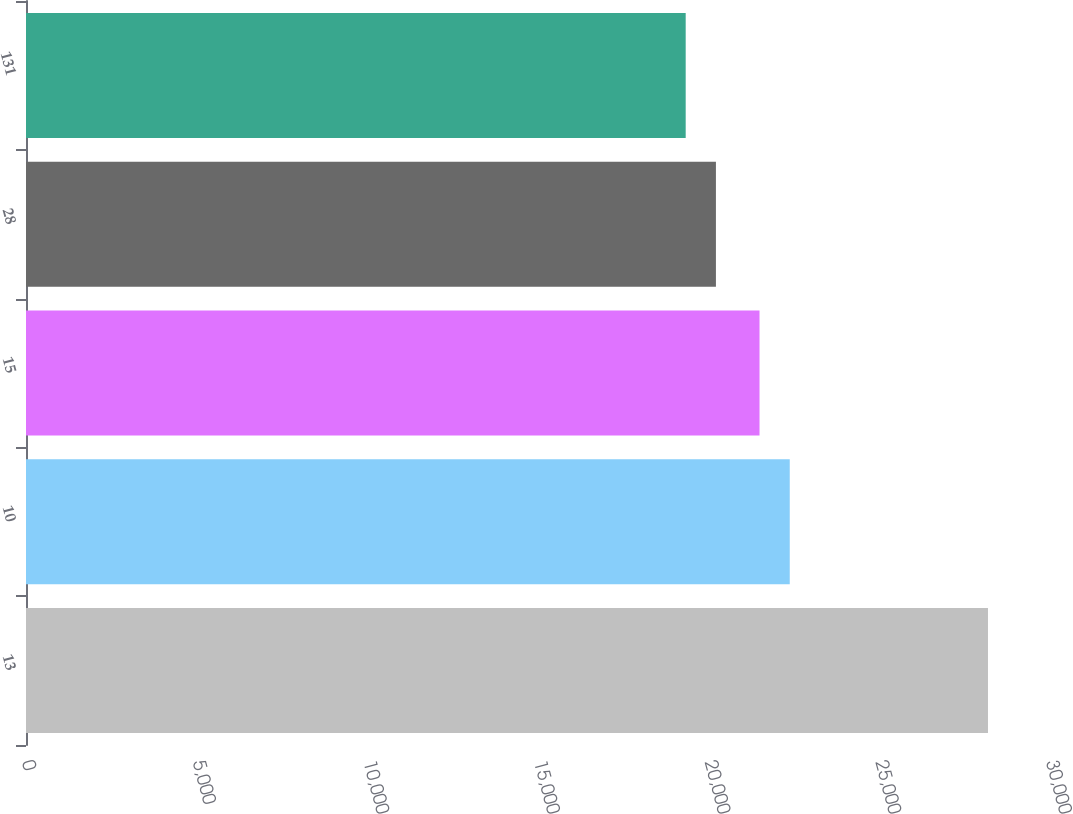<chart> <loc_0><loc_0><loc_500><loc_500><bar_chart><fcel>13<fcel>10<fcel>15<fcel>28<fcel>131<nl><fcel>28183<fcel>22375.6<fcel>21490<fcel>20212.6<fcel>19327<nl></chart> 